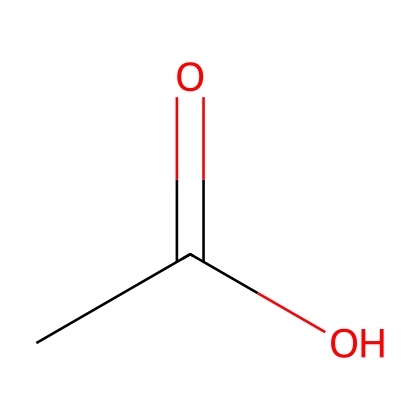What is the name of this chemical? The structure represented by the SMILES CC(=O)O is known as acetic acid. This can be identified by recognizing the carboxylic acid functional group (–COOH) present in the structure.
Answer: acetic acid How many oxygen atoms are in the chemical? In the structure CC(=O)O, there are two oxygen atoms: one in the carbonyl group (C=O) and one in the hydroxyl group (–OH) of the carboxylic acid.
Answer: 2 Is acetic acid a weak or strong acid? Acetic acid is classified as a weak acid because it only partially ionizes in water, meaning it does not fully dissociate into hydrogen ions (H+) and acetate ions (CH3COO–). This classification is based on its behavior in aqueous solutions.
Answer: weak acid What functional group characterizes acetic acid? The carboxylic acid functional group (–COOH) characterizes acetic acid. The presence of this group in the structure CC(=O)O indicates its acidic properties, such as donating protons in solution.
Answer: carboxylic acid What is a primary use of acetic acid in food preservation? A primary use of acetic acid in food preservation is as a preservative due to its ability to inhibit the growth of bacteria and fungi, effectively extending the shelf life of donated foods in food banks.
Answer: preservative 